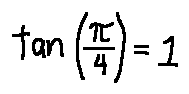<formula> <loc_0><loc_0><loc_500><loc_500>\tan ( \frac { \pi } { 4 } ) = 1</formula> 